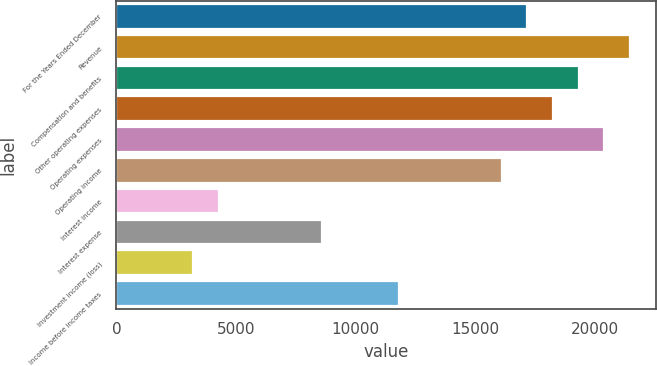Convert chart to OTSL. <chart><loc_0><loc_0><loc_500><loc_500><bar_chart><fcel>For the Years Ended December<fcel>Revenue<fcel>Compensation and benefits<fcel>Other operating expenses<fcel>Operating expenses<fcel>Operating income<fcel>Interest income<fcel>Interest expense<fcel>Investment income (loss)<fcel>Income before income taxes<nl><fcel>17168<fcel>21459.9<fcel>19314<fcel>18241<fcel>20386.9<fcel>16095<fcel>4292.09<fcel>8584.05<fcel>3219.1<fcel>11803<nl></chart> 